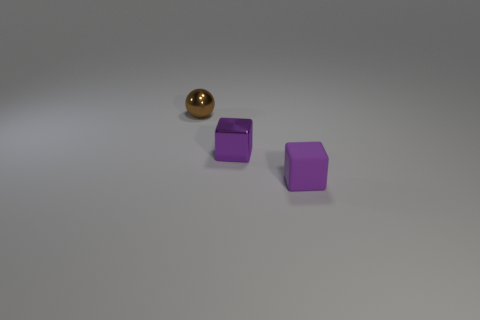Add 3 yellow rubber cubes. How many objects exist? 6 Subtract all balls. How many objects are left? 2 Subtract 0 blue cylinders. How many objects are left? 3 Subtract all large cyan rubber cylinders. Subtract all small metal objects. How many objects are left? 1 Add 2 cubes. How many cubes are left? 4 Add 2 tiny cubes. How many tiny cubes exist? 4 